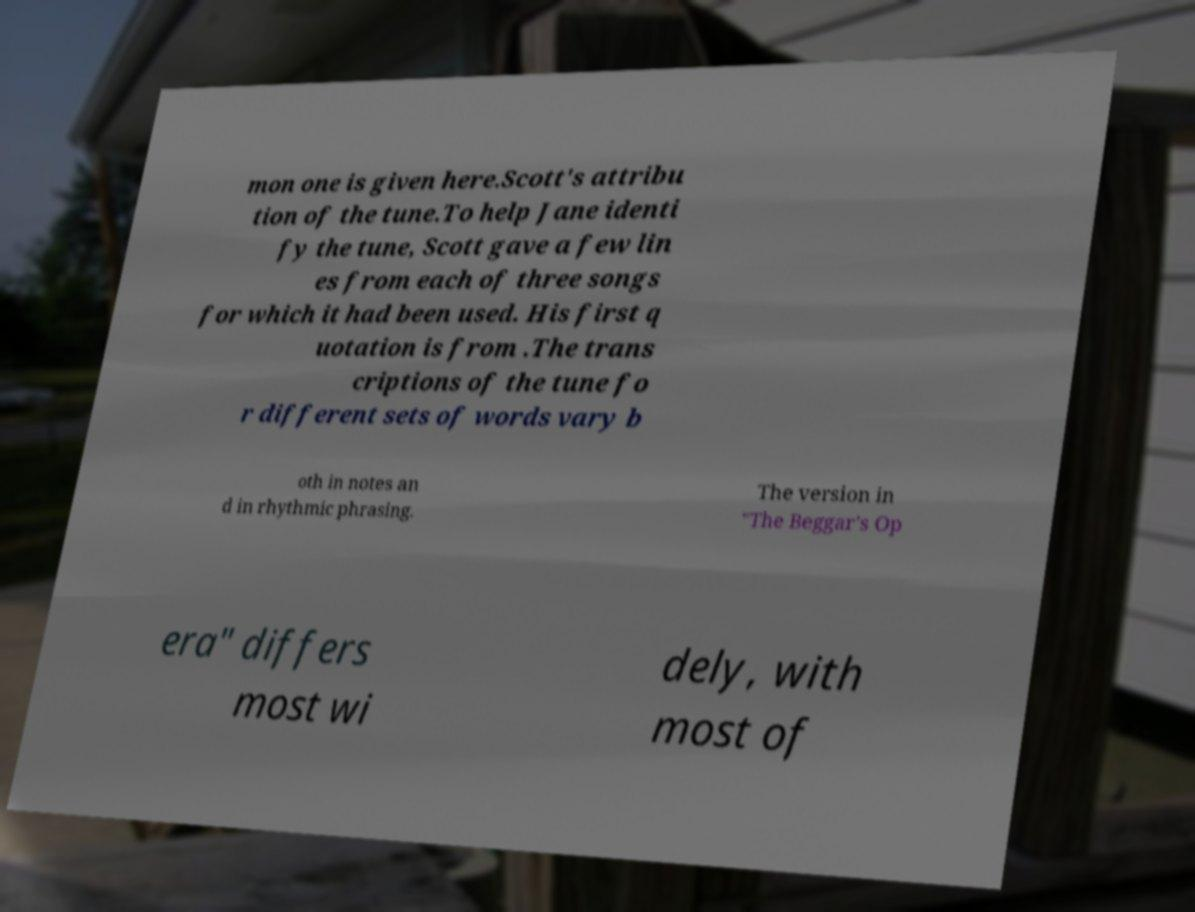For documentation purposes, I need the text within this image transcribed. Could you provide that? mon one is given here.Scott's attribu tion of the tune.To help Jane identi fy the tune, Scott gave a few lin es from each of three songs for which it had been used. His first q uotation is from .The trans criptions of the tune fo r different sets of words vary b oth in notes an d in rhythmic phrasing. The version in "The Beggar's Op era" differs most wi dely, with most of 